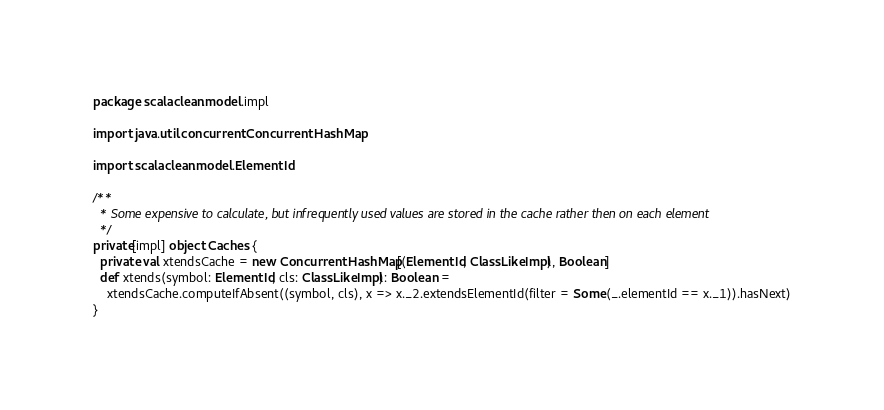<code> <loc_0><loc_0><loc_500><loc_500><_Scala_>package scalaclean.model.impl

import java.util.concurrent.ConcurrentHashMap

import scalaclean.model.ElementId

/**
  * Some expensive to calculate, but infrequently used values are stored in the cache rather then on each element
  */
private[impl] object Caches {
  private val xtendsCache = new ConcurrentHashMap[(ElementId, ClassLikeImpl), Boolean]
  def xtends(symbol: ElementId, cls: ClassLikeImpl): Boolean =
    xtendsCache.computeIfAbsent((symbol, cls), x => x._2.extendsElementId(filter = Some(_.elementId == x._1)).hasNext)
}
</code> 